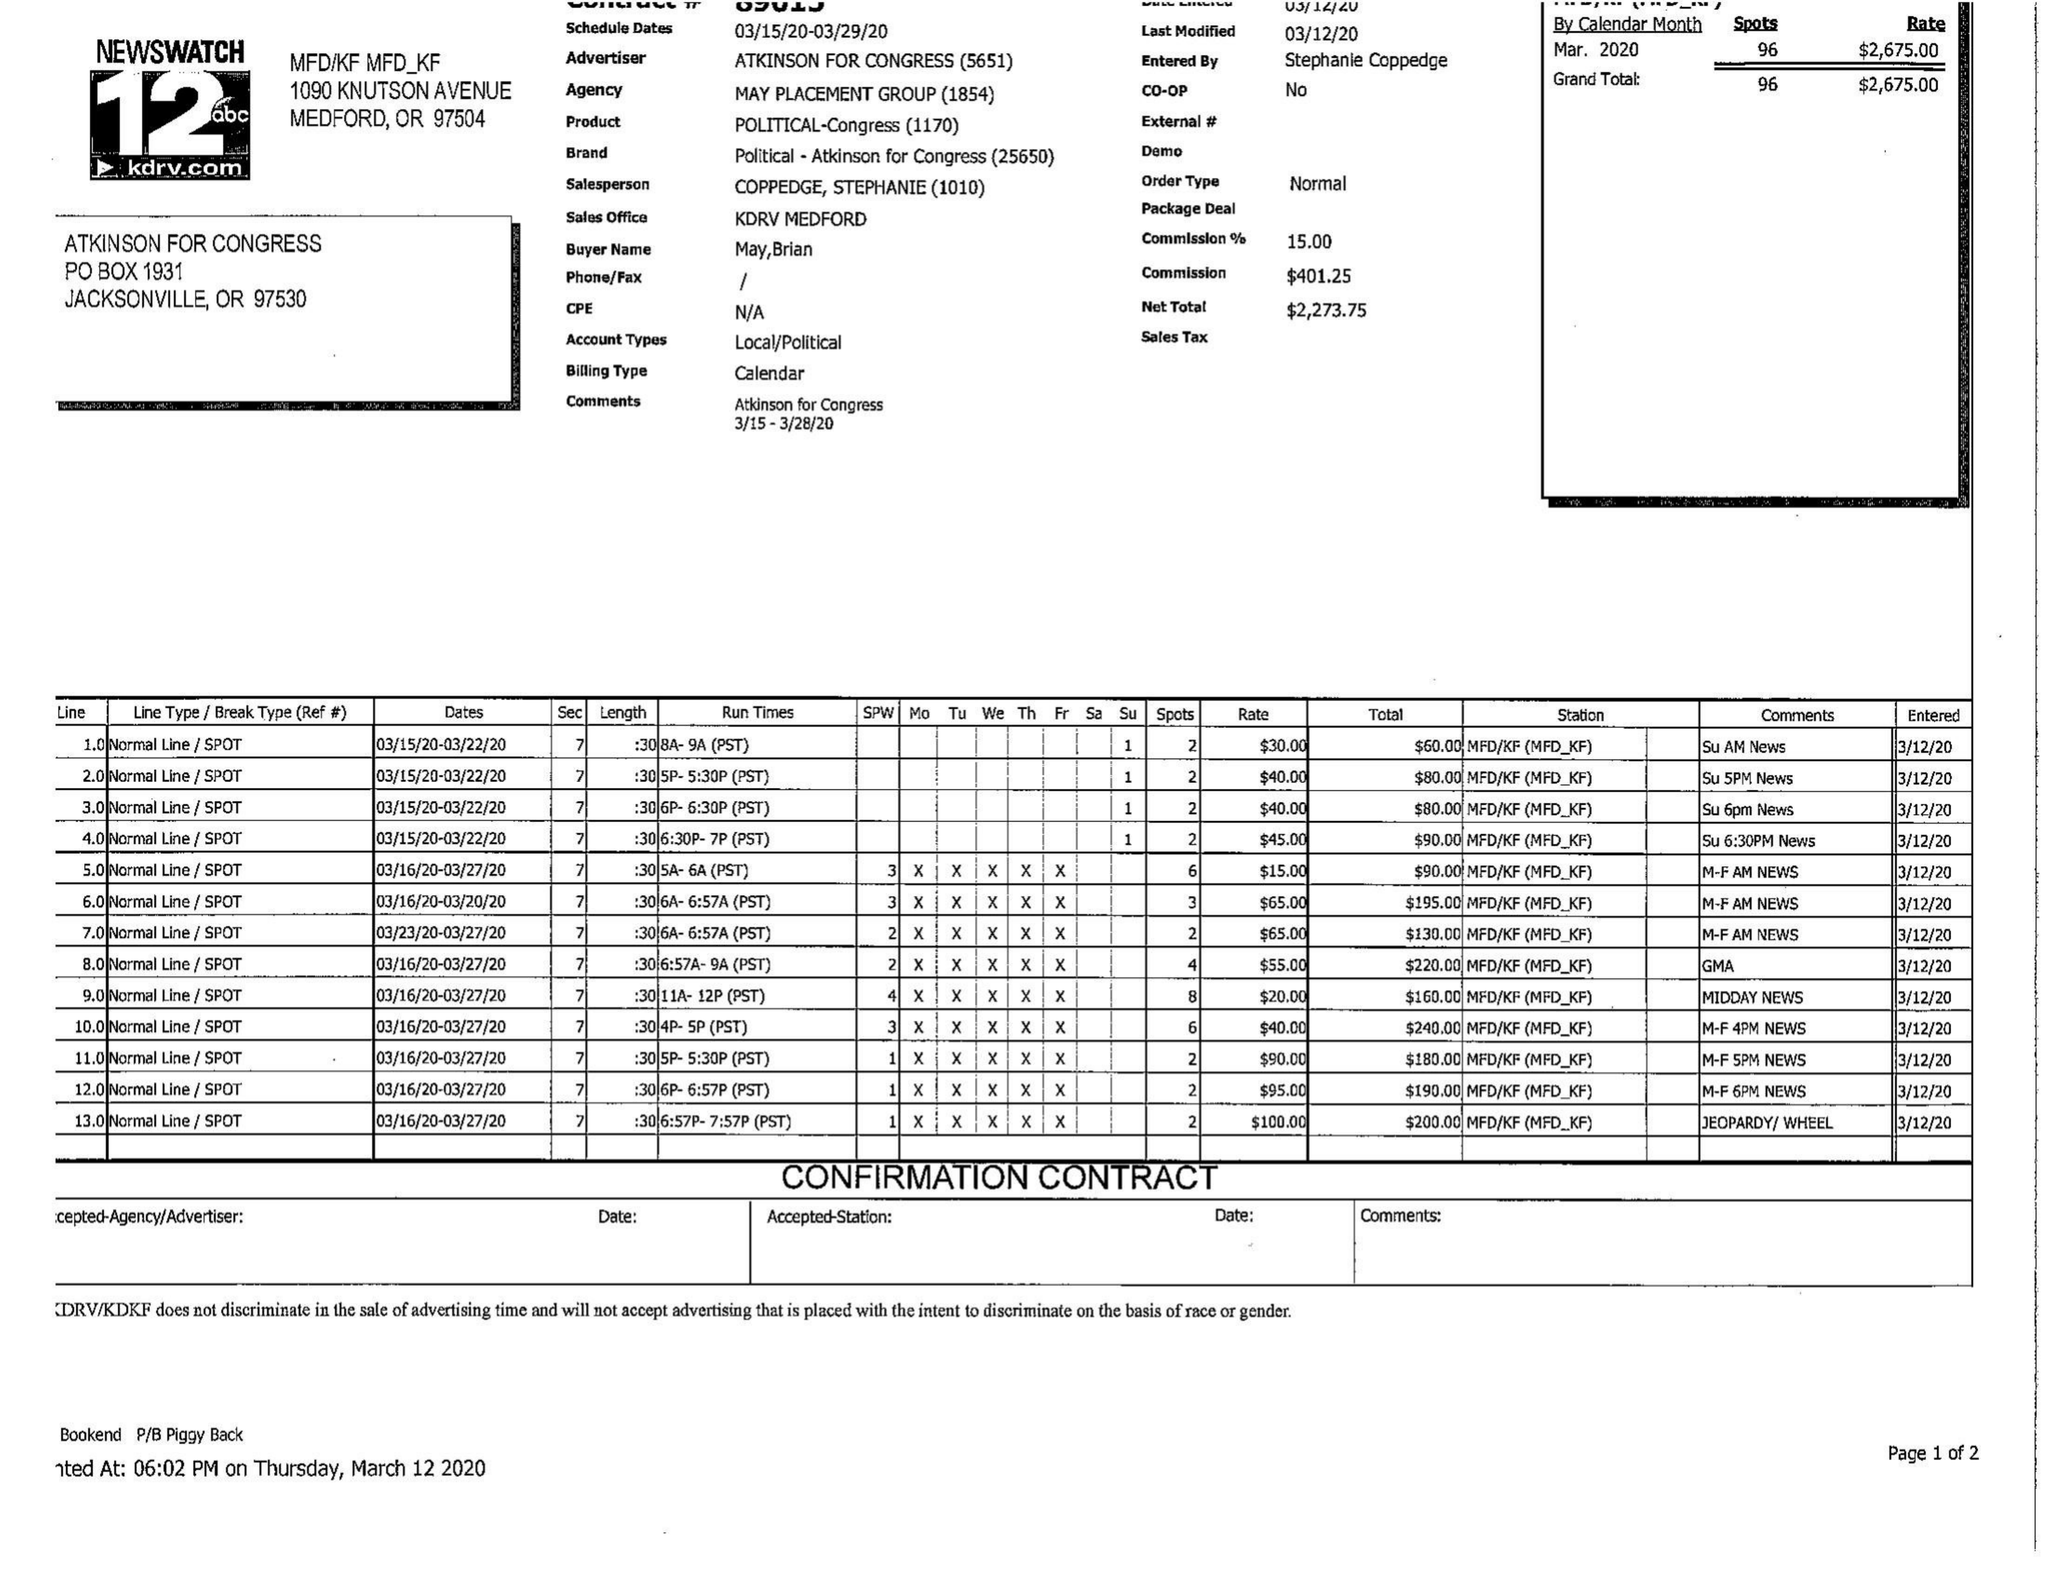What is the value for the flight_from?
Answer the question using a single word or phrase. 03/15/20 